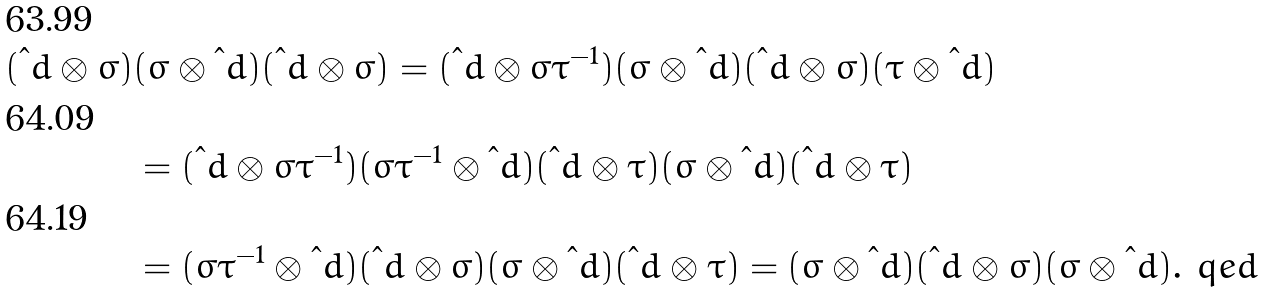<formula> <loc_0><loc_0><loc_500><loc_500>( \i d \otimes \sigma ) & ( \sigma \otimes \i d ) ( \i d \otimes \sigma ) = ( \i d \otimes \sigma \tau ^ { - 1 } ) ( \sigma \otimes \i d ) ( \i d \otimes \sigma ) ( \tau \otimes \i d ) \\ & = ( \i d \otimes \sigma \tau ^ { - 1 } ) ( \sigma \tau ^ { - 1 } \otimes \i d ) ( \i d \otimes \tau ) ( \sigma \otimes \i d ) ( \i d \otimes \tau ) \\ & = ( \sigma \tau ^ { - 1 } \otimes \i d ) ( \i d \otimes \sigma ) ( \sigma \otimes \i d ) ( \i d \otimes \tau ) = ( \sigma \otimes \i d ) ( \i d \otimes \sigma ) ( \sigma \otimes \i d ) . \ q e d</formula> 